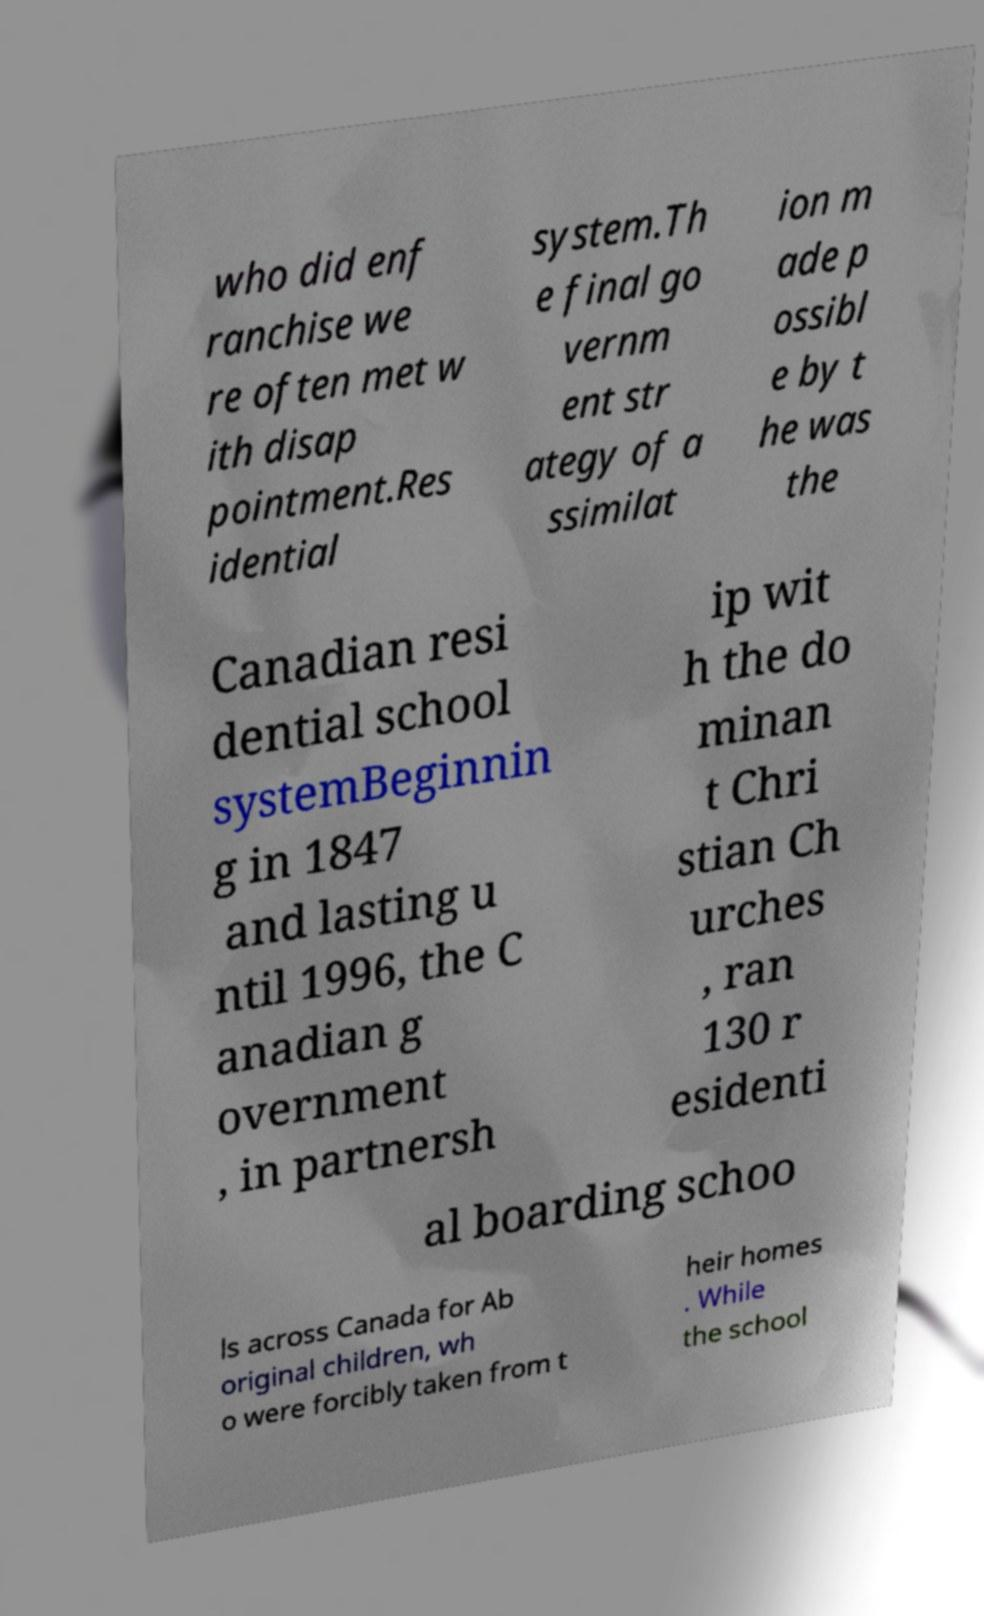I need the written content from this picture converted into text. Can you do that? who did enf ranchise we re often met w ith disap pointment.Res idential system.Th e final go vernm ent str ategy of a ssimilat ion m ade p ossibl e by t he was the Canadian resi dential school systemBeginnin g in 1847 and lasting u ntil 1996, the C anadian g overnment , in partnersh ip wit h the do minan t Chri stian Ch urches , ran 130 r esidenti al boarding schoo ls across Canada for Ab original children, wh o were forcibly taken from t heir homes . While the school 